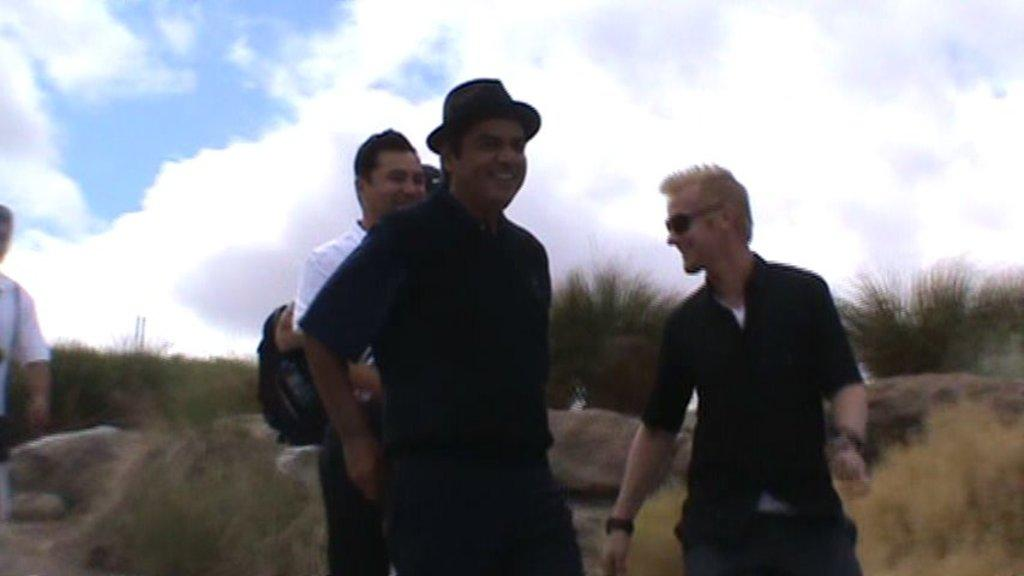What is the main subject of the image? There are people in the center of the image. What can be seen in the background of the image? There is grass in the background of the image. What type of objects are present in the image? There are stones in the image. What is visible at the top of the image? The sky is visible at the top of the image. What is the condition of the sky in the image? Clouds are present in the sky. What type of nerve can be seen in the image? There is no nerve present in the image. Can you provide an example of an airplane in the image? There is no airplane present in the image. 